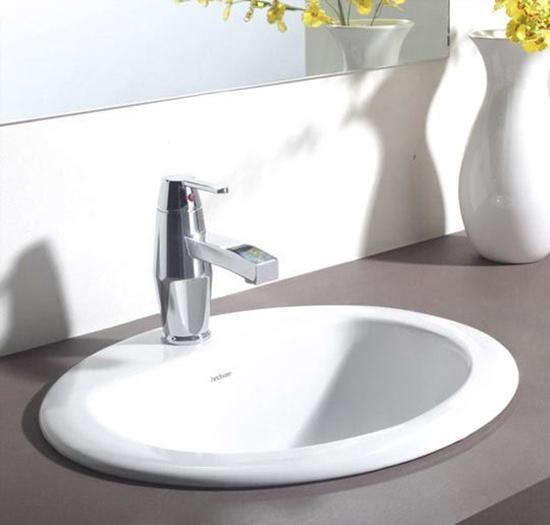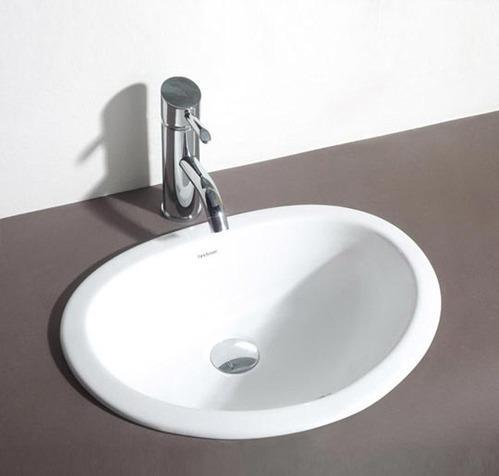The first image is the image on the left, the second image is the image on the right. Considering the images on both sides, is "In one of the images, there is a white vase with yellow flowers in it" valid? Answer yes or no. Yes. 